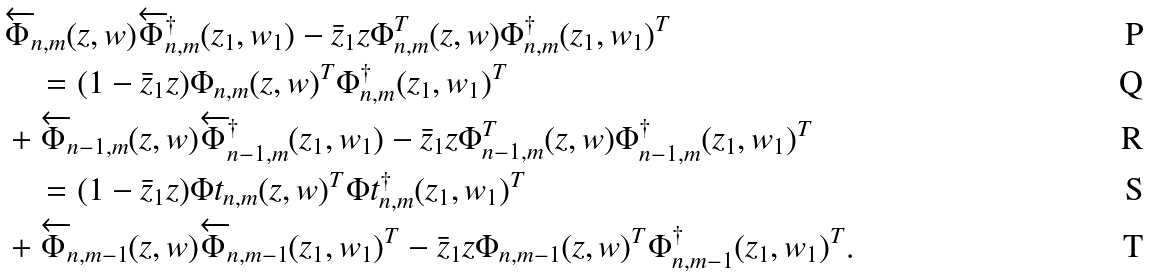Convert formula to latex. <formula><loc_0><loc_0><loc_500><loc_500>& \overleftarrow { \Phi } _ { n , m } ( z , w ) \overleftarrow { \Phi } ^ { \dagger } _ { n , m } ( z _ { 1 } , w _ { 1 } ) - \bar { z } _ { 1 } z \Phi _ { n , m } ^ { T } ( z , w ) \Phi ^ { \dagger } _ { n , m } ( z _ { 1 } , w _ { 1 } ) ^ { T } \\ & \quad = ( 1 - \bar { z } _ { 1 } z ) \Phi _ { n , m } ( z , w ) ^ { T } \Phi ^ { \dagger } _ { n , m } ( z _ { 1 } , w _ { 1 } ) ^ { T } \\ & + \overleftarrow { \Phi } _ { n - 1 , m } ( z , w ) \overleftarrow { \Phi } ^ { \dagger } _ { n - 1 , m } ( z _ { 1 } , w _ { 1 } ) - \bar { z } _ { 1 } z \Phi _ { n - 1 , m } ^ { T } ( z , w ) \Phi ^ { \dagger } _ { n - 1 , m } ( z _ { 1 } , w _ { 1 } ) ^ { T } \\ & \quad = ( 1 - \bar { z } _ { 1 } z ) \Phi t _ { n , m } ( z , w ) ^ { T } \Phi t ^ { \dagger } _ { n , m } ( z _ { 1 } , w _ { 1 } ) ^ { T } \\ & + \overleftarrow { \Phi } _ { n , m - 1 } ( z , w ) \overleftarrow { \Phi } _ { n , m - 1 } ( z _ { 1 } , w _ { 1 } ) ^ { T } - \bar { z } _ { 1 } z \Phi _ { n , m - 1 } ( z , w ) ^ { T } \Phi ^ { \dagger } _ { n , m - 1 } ( z _ { 1 } , w _ { 1 } ) ^ { T } .</formula> 